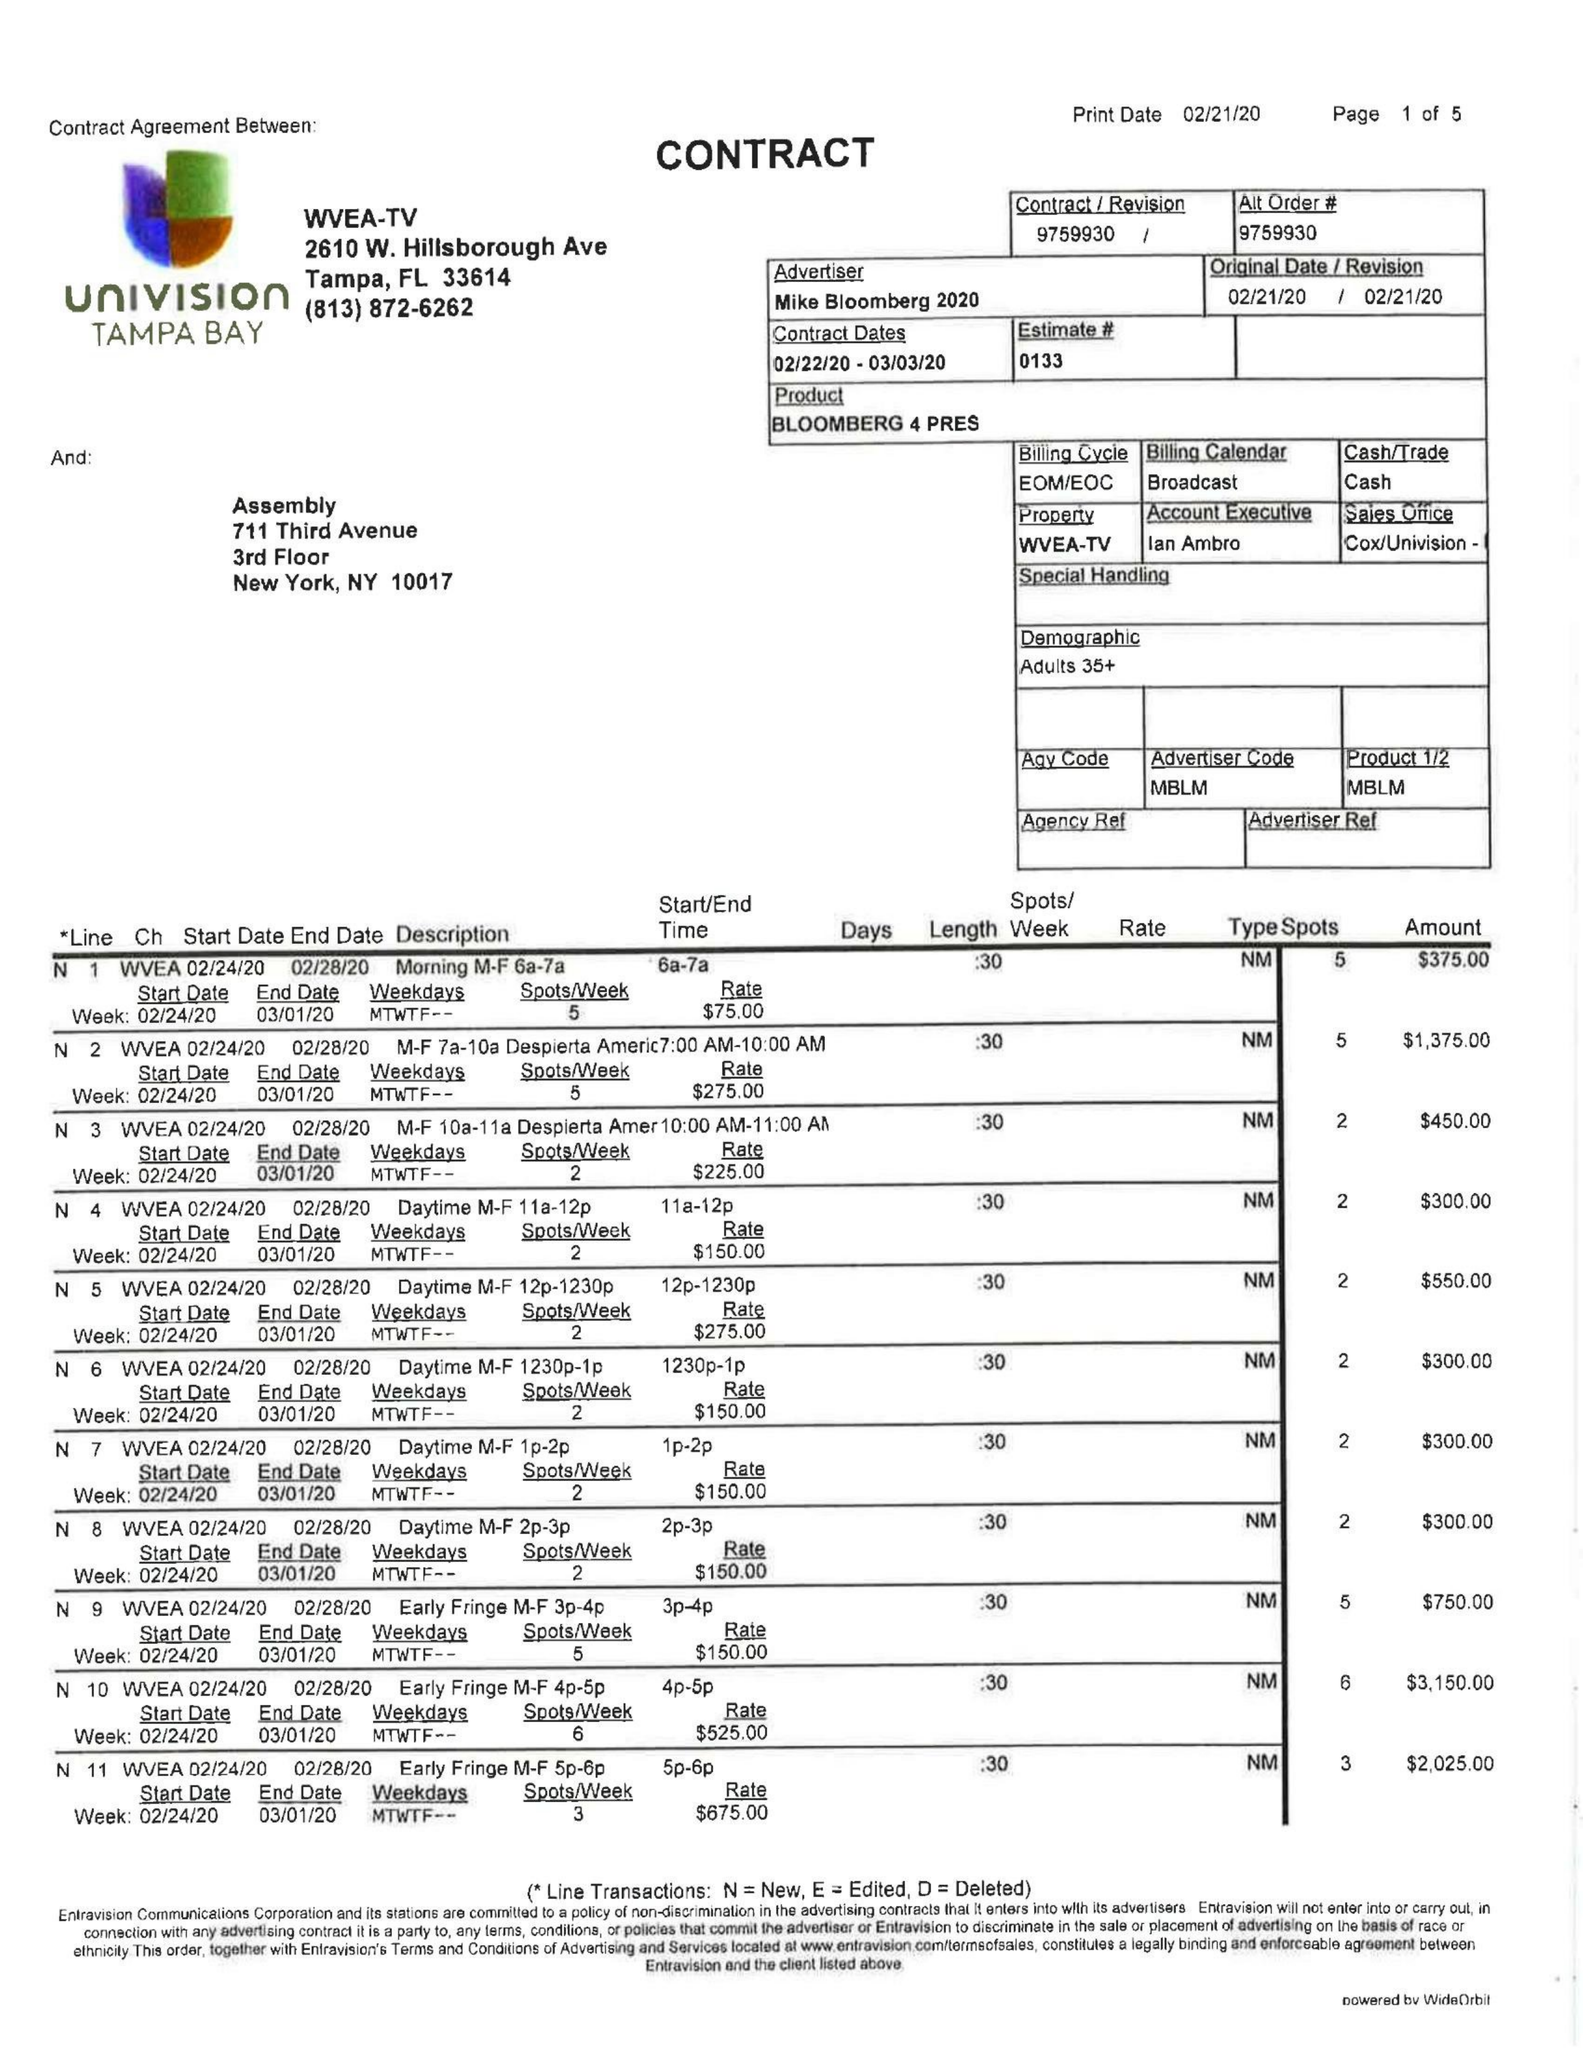What is the value for the contract_num?
Answer the question using a single word or phrase. 9759930 